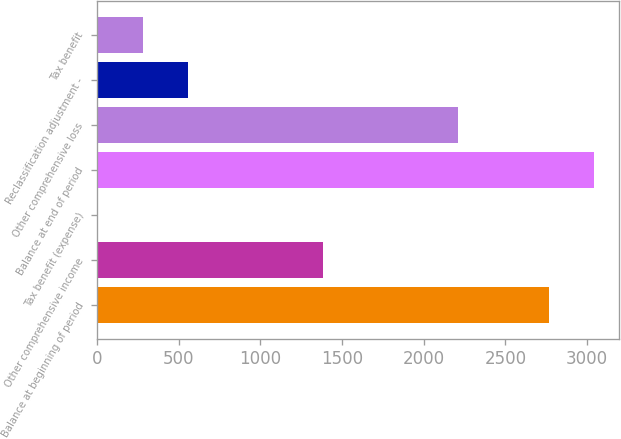Convert chart. <chart><loc_0><loc_0><loc_500><loc_500><bar_chart><fcel>Balance at beginning of period<fcel>Other comprehensive income<fcel>Tax benefit (expense)<fcel>Balance at end of period<fcel>Other comprehensive loss<fcel>Reclassification adjustment -<fcel>Tax benefit<nl><fcel>2765<fcel>1384<fcel>3<fcel>3041.2<fcel>2212.6<fcel>555.4<fcel>279.2<nl></chart> 